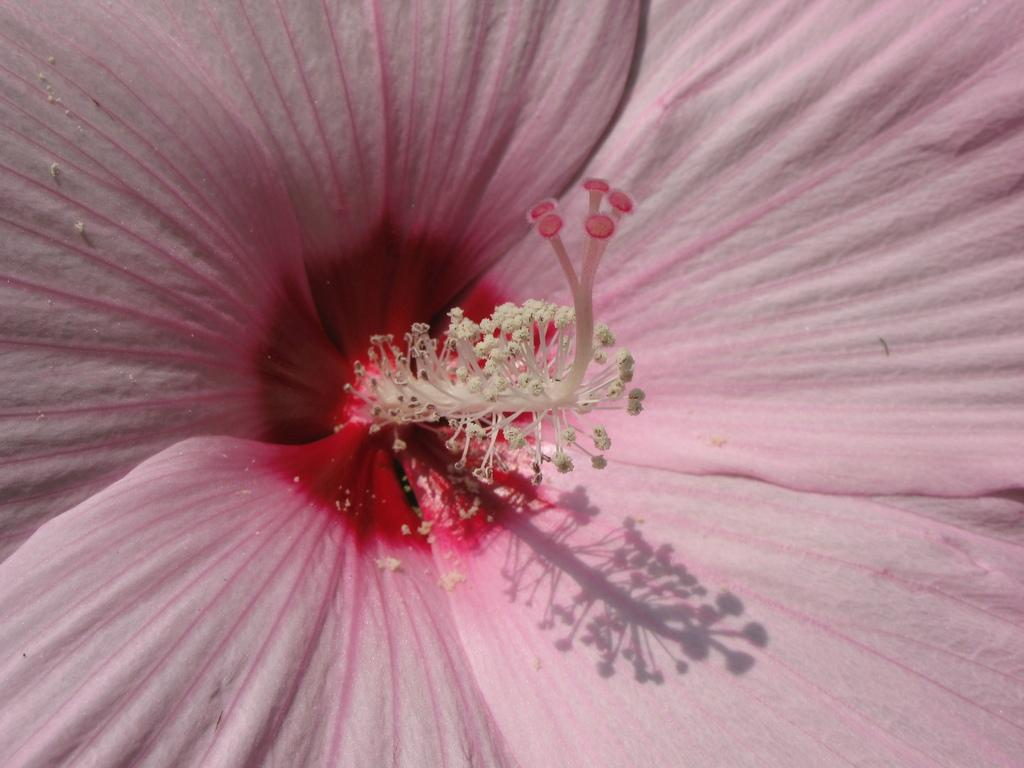What is the main subject of the image? The main subject of the image is a pink color flower. Can you describe any specific details about the flower? Pollen grains are visible in the image. What year is depicted in the image? The image does not depict a specific year; it is a close-up picture of a flower. How many attempts were made to paint the flower in the image? The image is a photograph, not a painting, so there were no attempts made to paint the flower. 